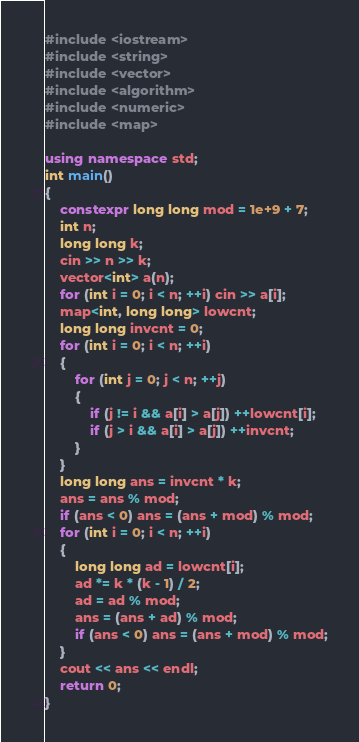Convert code to text. <code><loc_0><loc_0><loc_500><loc_500><_C++_>#include <iostream>
#include <string>
#include <vector>
#include <algorithm>
#include <numeric>
#include <map>

using namespace std;
int main()
{
    constexpr long long mod = 1e+9 + 7;
    int n;
    long long k;
    cin >> n >> k;
    vector<int> a(n);
    for (int i = 0; i < n; ++i) cin >> a[i];
    map<int, long long> lowcnt;
    long long invcnt = 0;
    for (int i = 0; i < n; ++i)
    {
        for (int j = 0; j < n; ++j)
        {
            if (j != i && a[i] > a[j]) ++lowcnt[i];
            if (j > i && a[i] > a[j]) ++invcnt;
        }
    }
    long long ans = invcnt * k;
    ans = ans % mod;
    if (ans < 0) ans = (ans + mod) % mod;
    for (int i = 0; i < n; ++i)
    {
        long long ad = lowcnt[i];
        ad *= k * (k - 1) / 2;
        ad = ad % mod;
        ans = (ans + ad) % mod;
        if (ans < 0) ans = (ans + mod) % mod;
    }
    cout << ans << endl;
    return 0;
}
</code> 